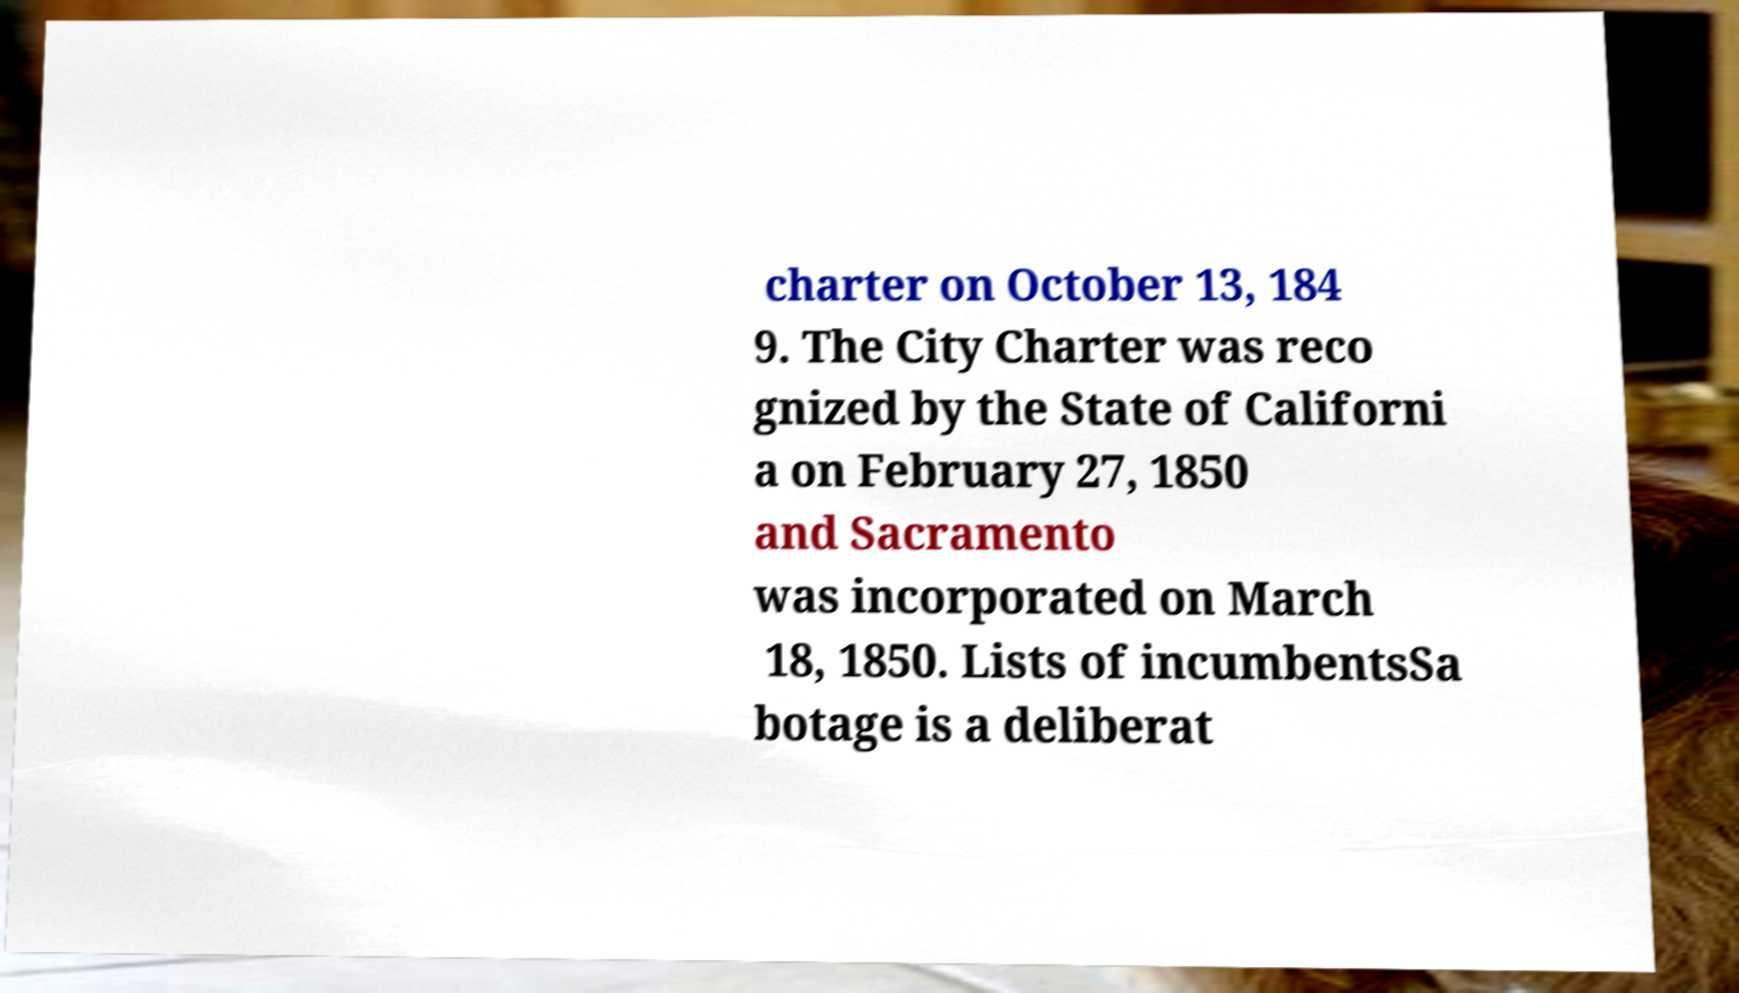For documentation purposes, I need the text within this image transcribed. Could you provide that? charter on October 13, 184 9. The City Charter was reco gnized by the State of Californi a on February 27, 1850 and Sacramento was incorporated on March 18, 1850. Lists of incumbentsSa botage is a deliberat 